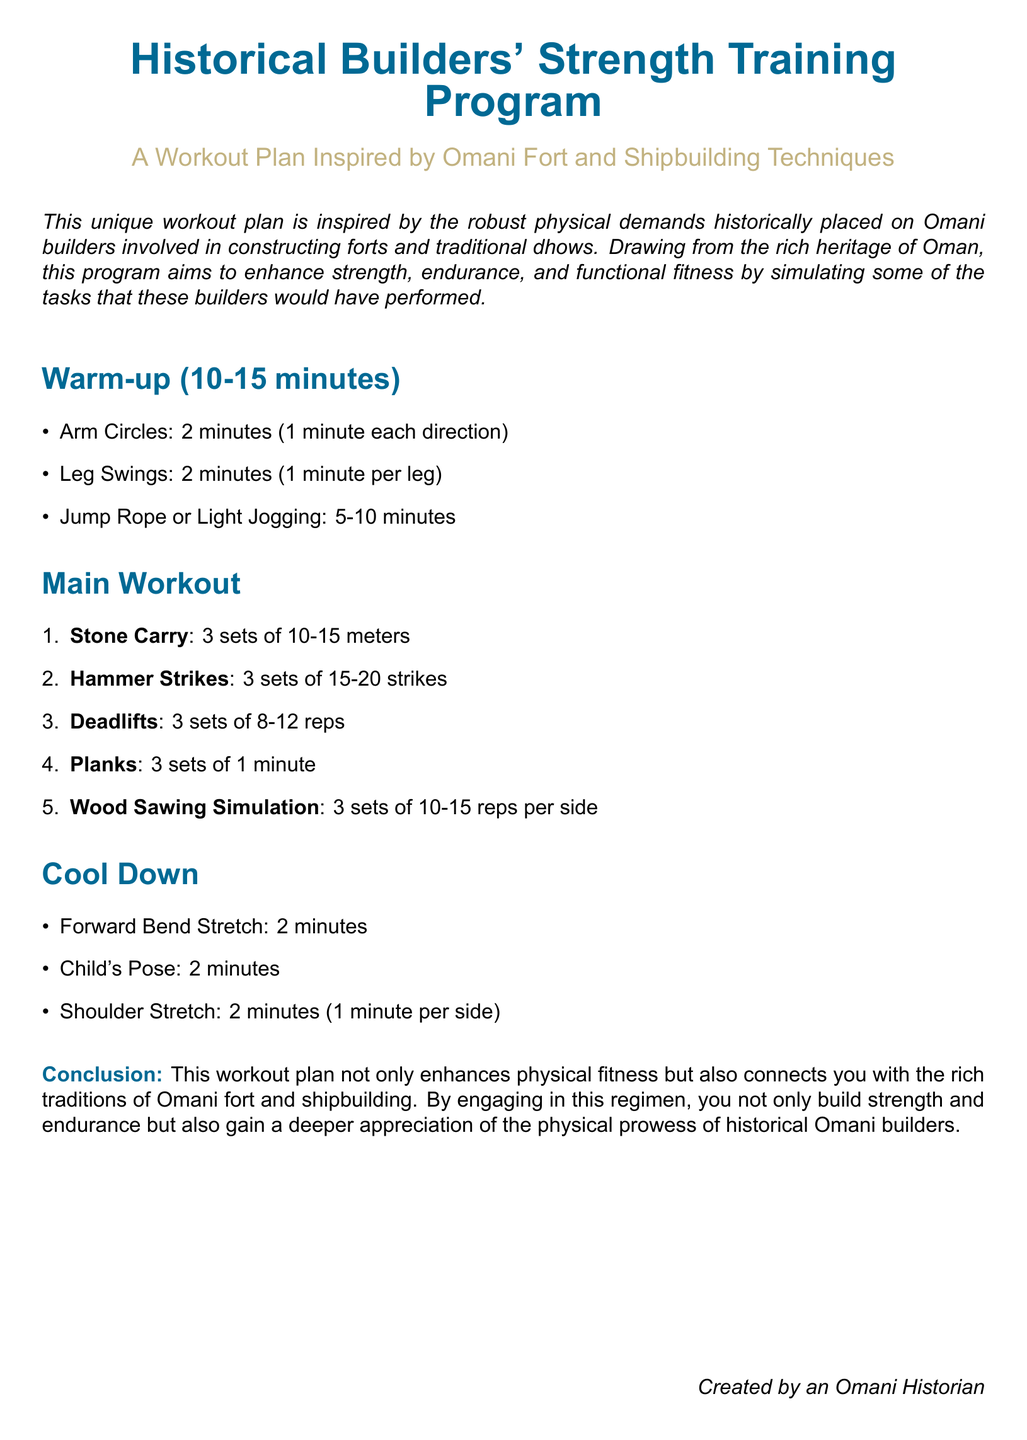What is the title of the workout plan? The title of the workout plan is stated at the top of the document.
Answer: Historical Builders' Strength Training Program How long is the warm-up section? The document specifies the duration for the warm-up section.
Answer: 10-15 minutes What is one exercise included in the main workout? The main workout section lists specific exercises; one can be mentioned here.
Answer: Stone Carry How many sets of planks should be performed? The number of sets for planks is specified in the main workout section.
Answer: 3 sets How long should the forward bend stretch be held? The duration for the forward bend stretch is mentioned in the cool-down section.
Answer: 2 minutes Why was this workout plan created? The document provides a purpose for creating this workout plan.
Answer: Connect with the rich traditions of Omani fort and shipbuilding What is the aim of this workout plan? The document outlines the general objective of the workout plan.
Answer: Enhance strength, endurance, and functional fitness How many hammer strikes should be performed in a set? The number of hammer strikes per set is mentioned in the main workout.
Answer: 15-20 strikes 